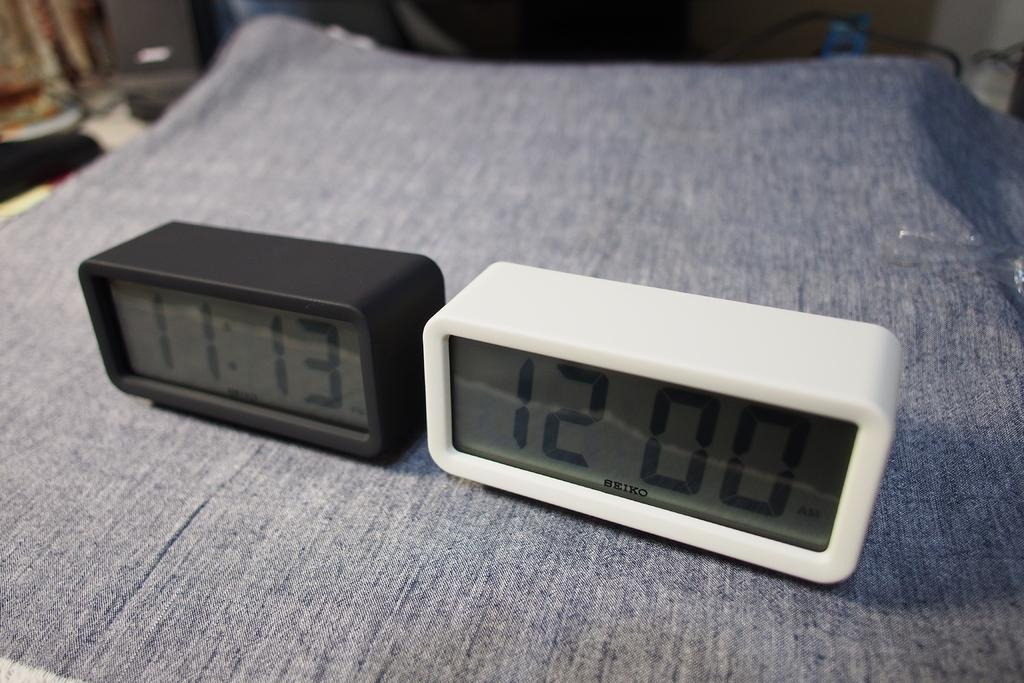Provide a one-sentence caption for the provided image. Black and white digital clocks with the white clock showing 12. 